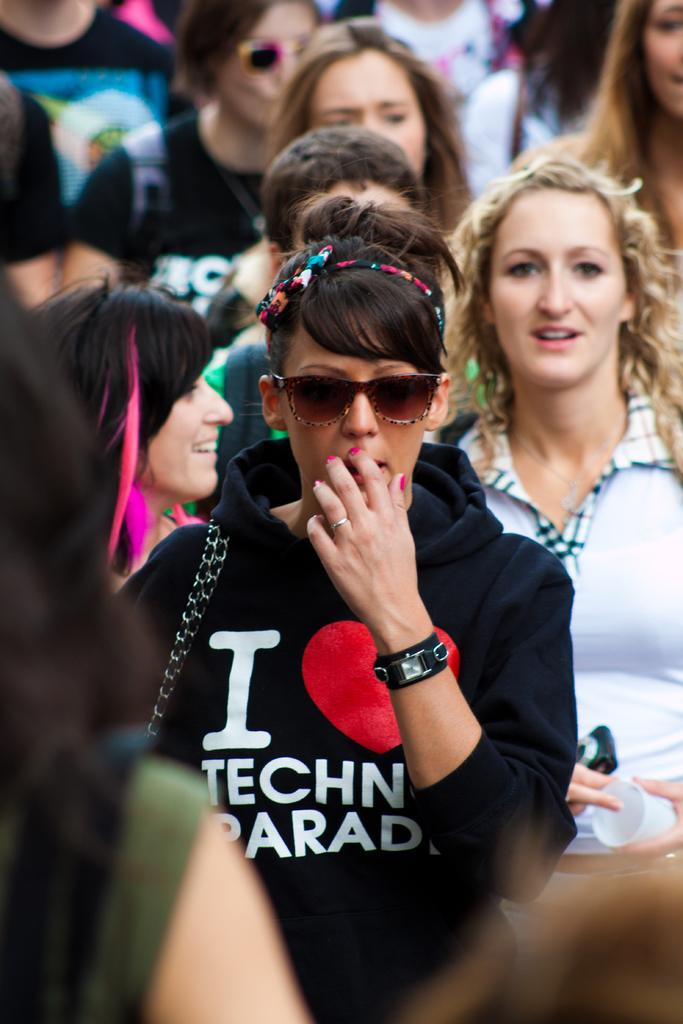What is the person in the image wearing on their face? The person in the image is wearing goggles. What type of clothing is the person wearing? The person is wearing a black hoodie. Can you describe the people in the background of the image? There is a group of people in the background of the image. What type of prison is depicted in the image? There is no prison present in the image. Can you describe the to me the toad that is sitting on the person's shoulder in the image? There is no toad present in the image. 